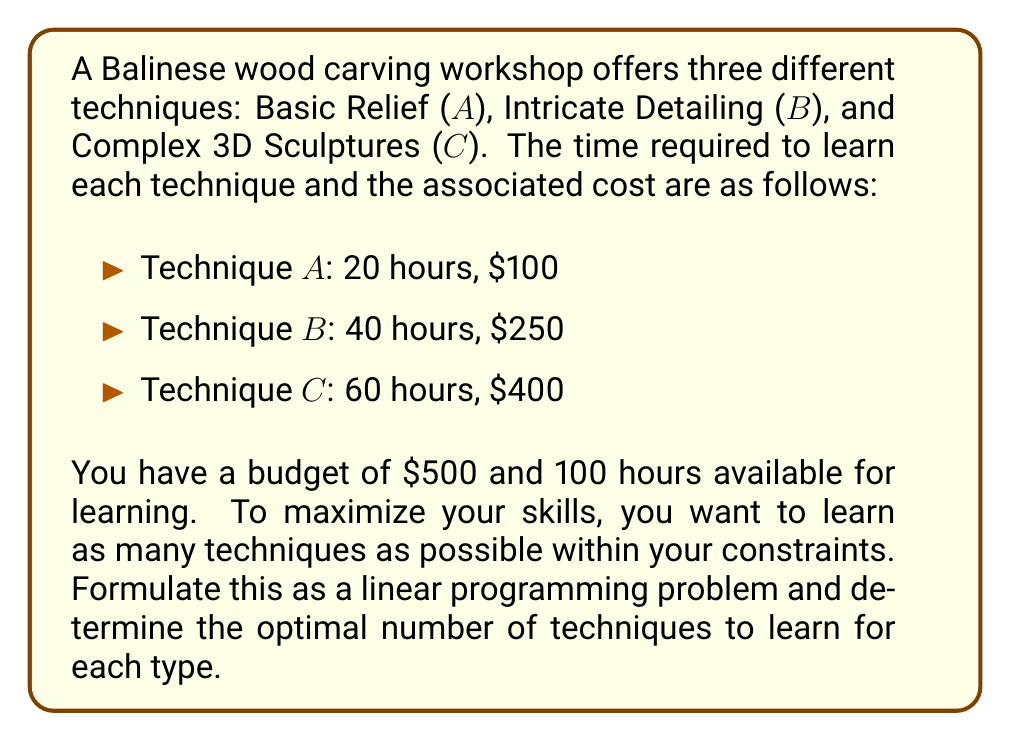What is the answer to this math problem? To solve this problem, we'll use linear programming. Let's define our variables:

$x_A$ = number of times to learn technique A
$x_B$ = number of times to learn technique B
$x_C$ = number of times to learn technique C

Objective function (maximize the total number of techniques learned):
$$\text{Maximize } Z = x_A + x_B + x_C$$

Constraints:
1. Time constraint: $20x_A + 40x_B + 60x_C \leq 100$
2. Budget constraint: $100x_A + 250x_B + 400x_C \leq 500$
3. Non-negativity: $x_A, x_B, x_C \geq 0$
4. Integer constraint: $x_A, x_B, x_C$ must be integers

This is an Integer Linear Programming (ILP) problem. We can solve it using the following steps:

1. Relax the integer constraint and solve as a regular LP problem.
2. Use the simplex method or graphical method to find the optimal solution.
3. Round down the solution to the nearest integer values.

Solving the relaxed LP problem:

The feasible region is bounded by the two constraints and the non-negativity constraints. The optimal solution will be at one of the corner points of this region.

Corner points:
(0, 0, 0), (5, 0, 0), (2.5, 1, 0), (0, 2, 0), (0, 0, 1.67)

Evaluating Z at these points:
(0, 0, 0): Z = 0
(5, 0, 0): Z = 5
(2.5, 1, 0): Z = 3.5
(0, 2, 0): Z = 2
(0, 0, 1.67): Z = 1.67

The maximum value of Z is 5, occurring at the point (5, 0, 0).

Rounding down to satisfy the integer constraint:

$x_A = 5$, $x_B = 0$, $x_C = 0$

This solution satisfies all constraints:
Time: $20(5) + 40(0) + 60(0) = 100 \leq 100$
Budget: $100(5) + 250(0) + 400(0) = 500 \leq 500$
Answer: The optimal solution is to learn Technique A (Basic Relief) 5 times, maximizing the number of techniques learned within the given constraints. 